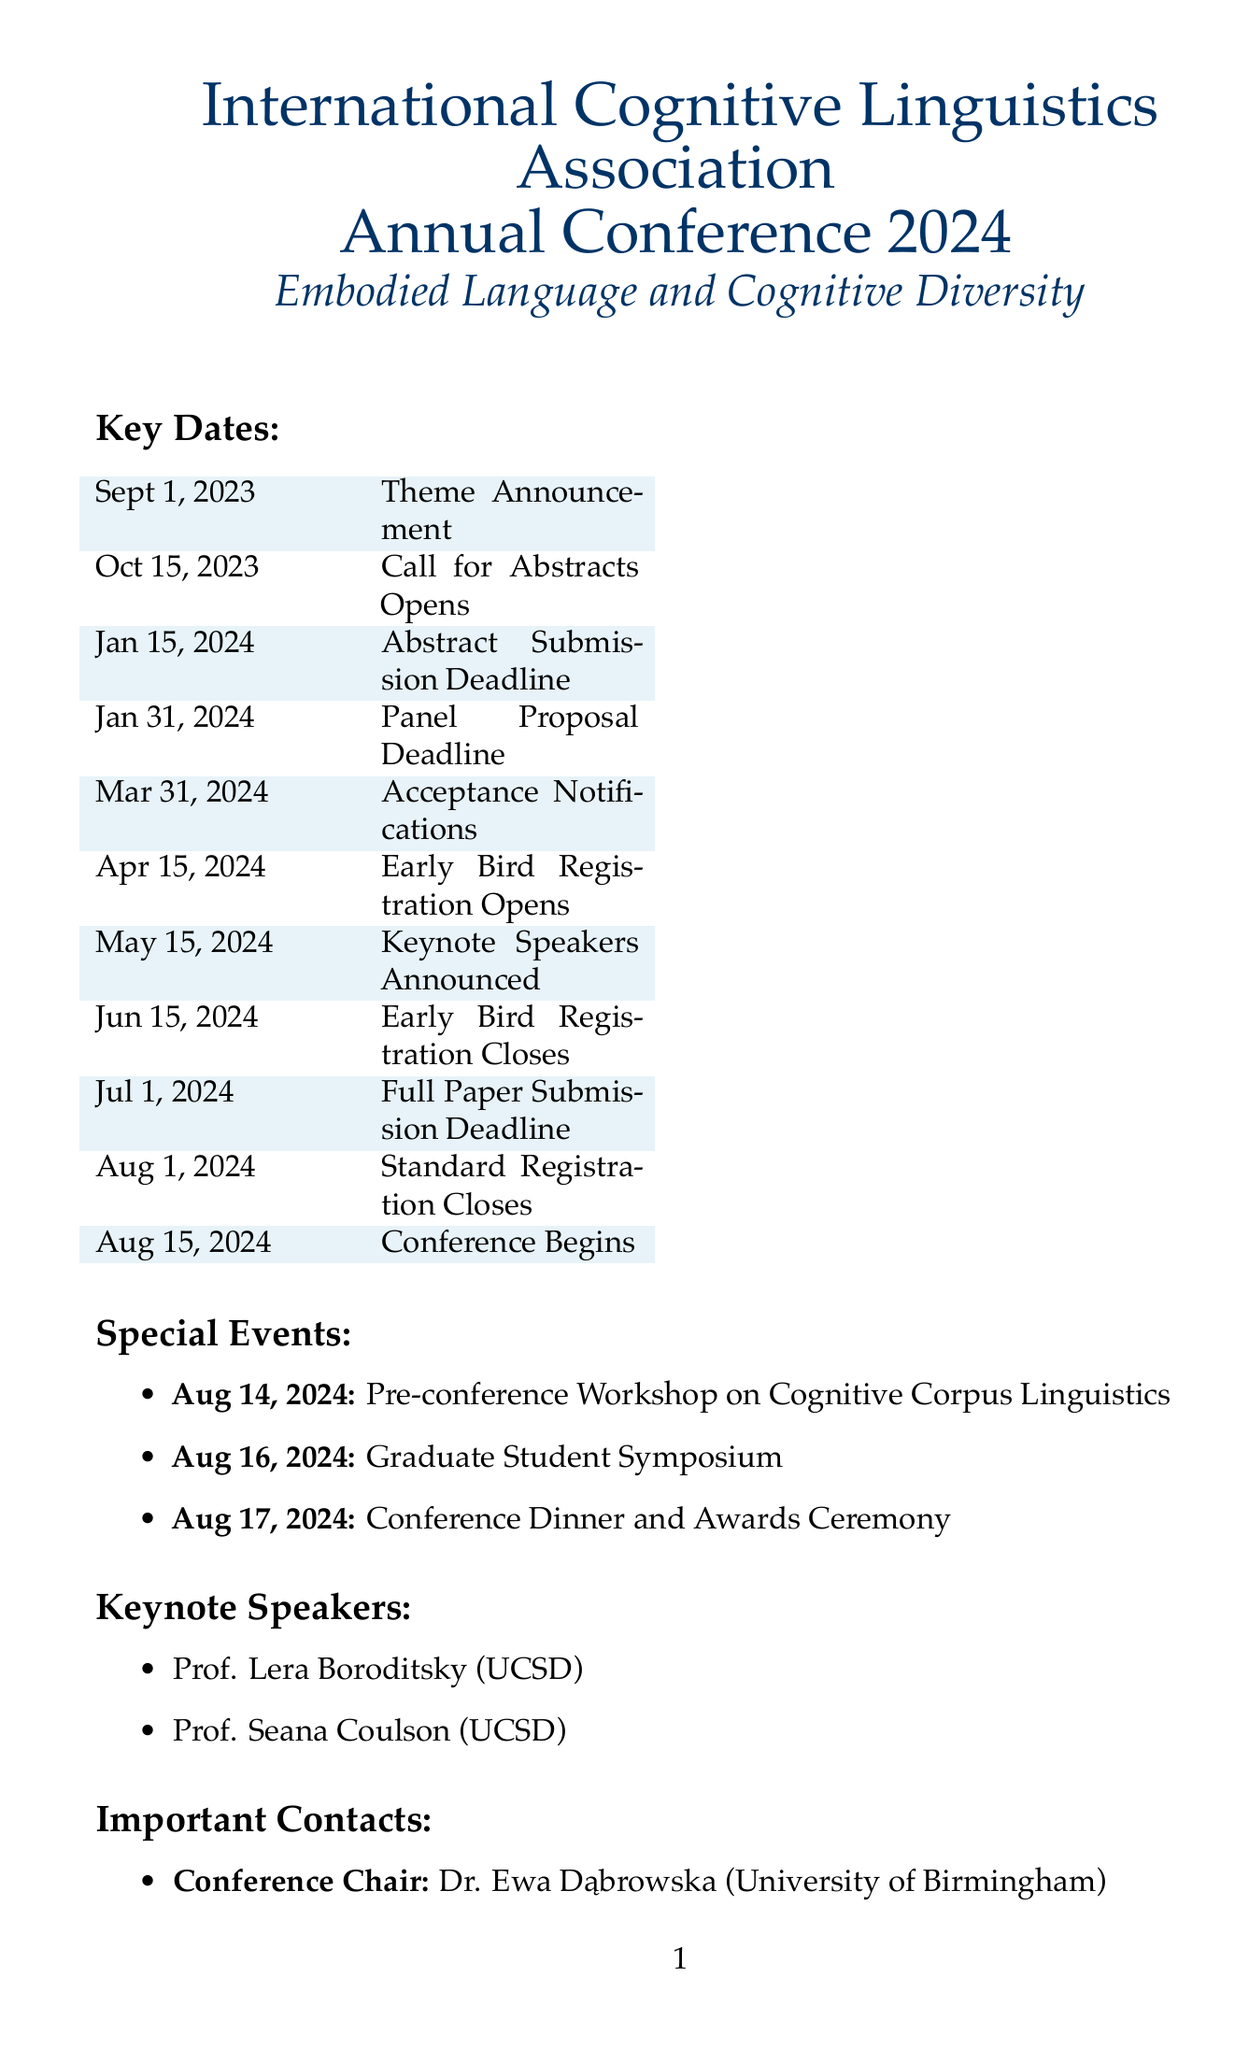What is the theme of the conference? The theme of the conference is announced to reflect current trends in cognitive linguistics research, specifically 'Embodied Language and Cognitive Diversity'.
Answer: Embodied Language and Cognitive Diversity When does the call for abstract submissions open? The call for abstract submissions is a task listed in the timeline on a specific date, which is October 15, 2023.
Answer: October 15, 2023 What is the word limit for abstract submissions? The details for the abstract submissions specify that abstracts are limited to a particular word count.
Answer: 300 words Who will lead the abstract review process? The document specifies that Dr. Elena Martínez from the University of Barcelona will lead the review committee for abstracts.
Answer: Dr. Elena Martínez When does early bird registration open? The timeline includes the opening date for early bird registration, specifically on April 15, 2024.
Answer: April 15, 2024 What is the deadline for panel proposals? The document provides a deadline date for panel proposals as part of the planning timeline.
Answer: January 31, 2024 How many speakers should be included in panel proposals? The guidelines for panel proposals specify a required number of speakers to achieve a cohesive theme.
Answer: 3-5 speakers What is a special event scheduled for August 14, 2024? The document highlights a specific event taking place on this date, which is a workshop dedicated to a topic in cognitive linguistics.
Answer: Pre-conference Workshop Who is the Conference Chair? The document lists the individual fulfilling the role of the Conference Chair and their affiliation.
Answer: Dr. Ewa Dąbrowska 